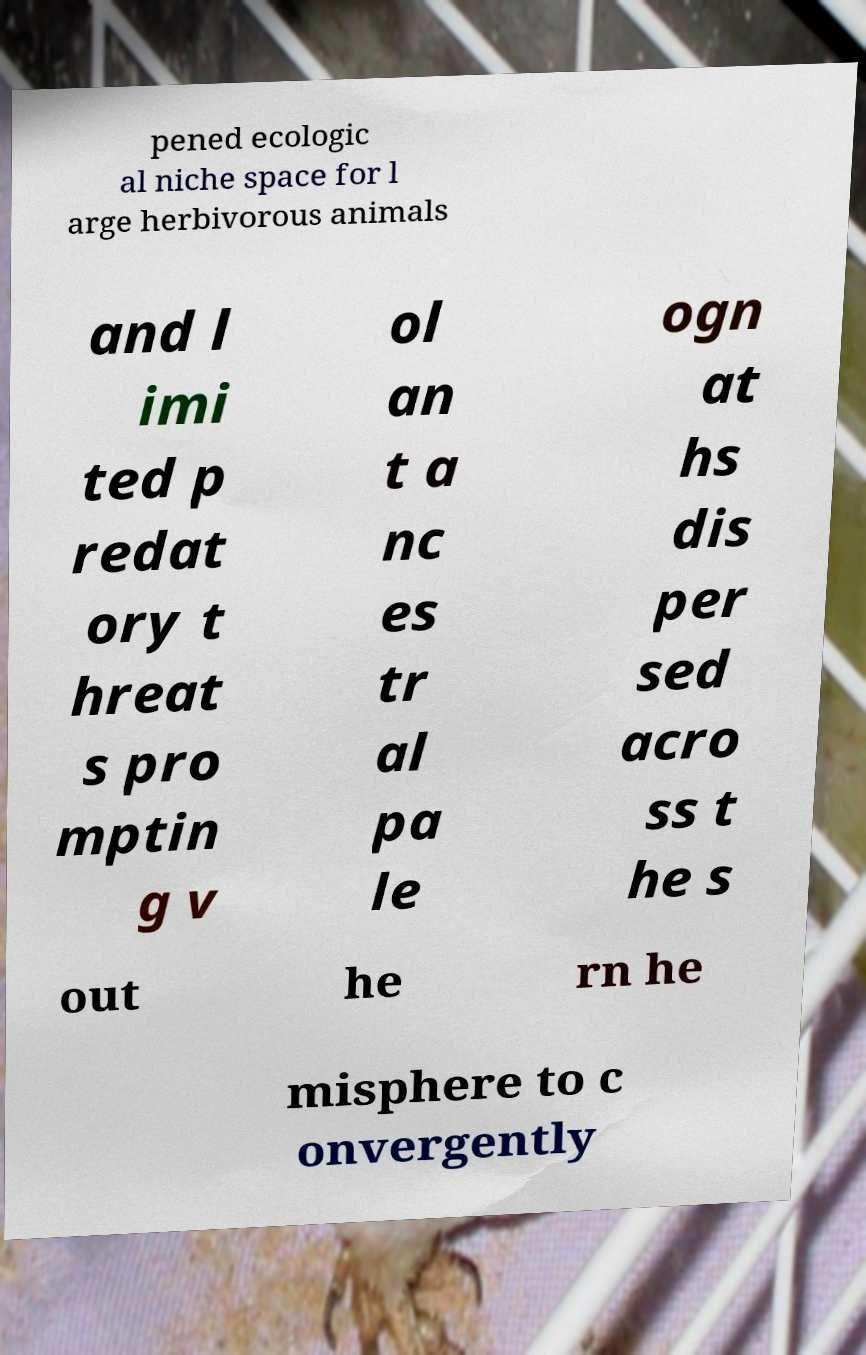There's text embedded in this image that I need extracted. Can you transcribe it verbatim? pened ecologic al niche space for l arge herbivorous animals and l imi ted p redat ory t hreat s pro mptin g v ol an t a nc es tr al pa le ogn at hs dis per sed acro ss t he s out he rn he misphere to c onvergently 